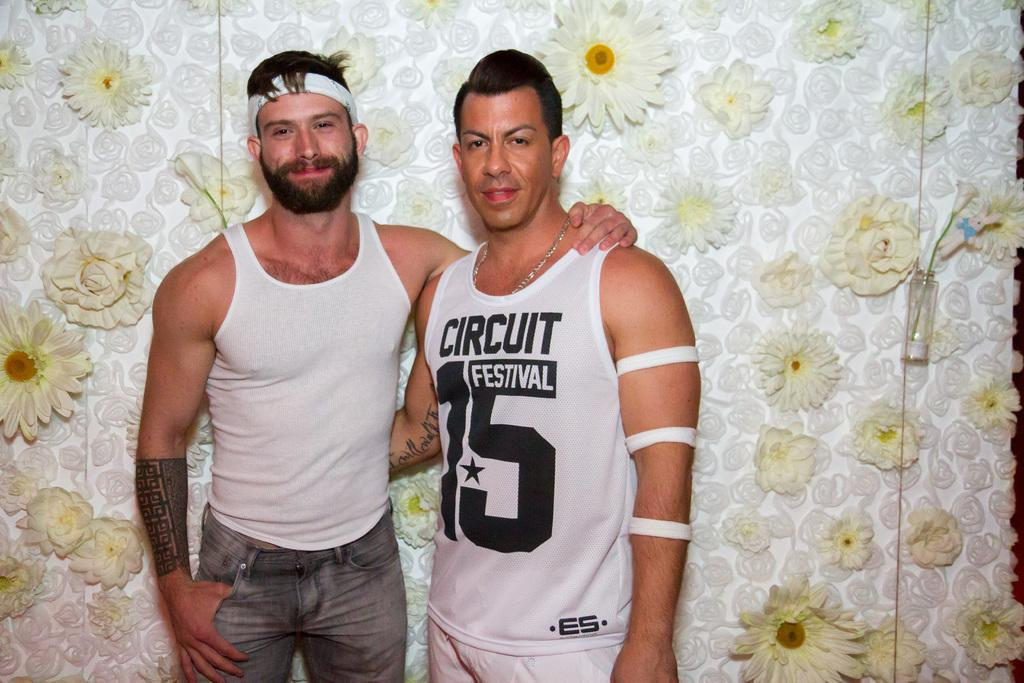<image>
Share a concise interpretation of the image provided. the number 15 is on the shirt of a person 